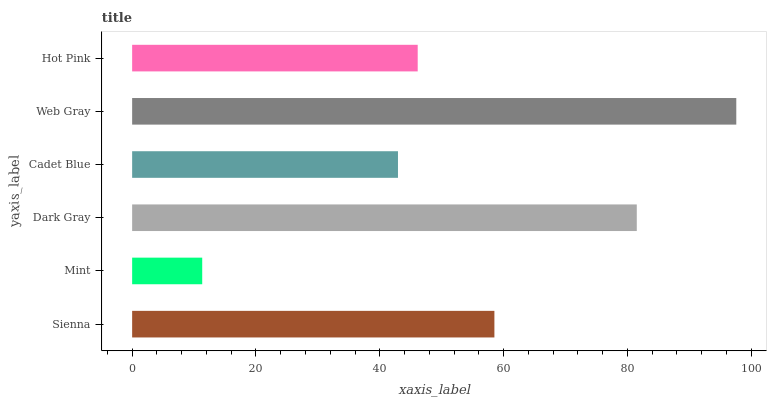Is Mint the minimum?
Answer yes or no. Yes. Is Web Gray the maximum?
Answer yes or no. Yes. Is Dark Gray the minimum?
Answer yes or no. No. Is Dark Gray the maximum?
Answer yes or no. No. Is Dark Gray greater than Mint?
Answer yes or no. Yes. Is Mint less than Dark Gray?
Answer yes or no. Yes. Is Mint greater than Dark Gray?
Answer yes or no. No. Is Dark Gray less than Mint?
Answer yes or no. No. Is Sienna the high median?
Answer yes or no. Yes. Is Hot Pink the low median?
Answer yes or no. Yes. Is Hot Pink the high median?
Answer yes or no. No. Is Dark Gray the low median?
Answer yes or no. No. 